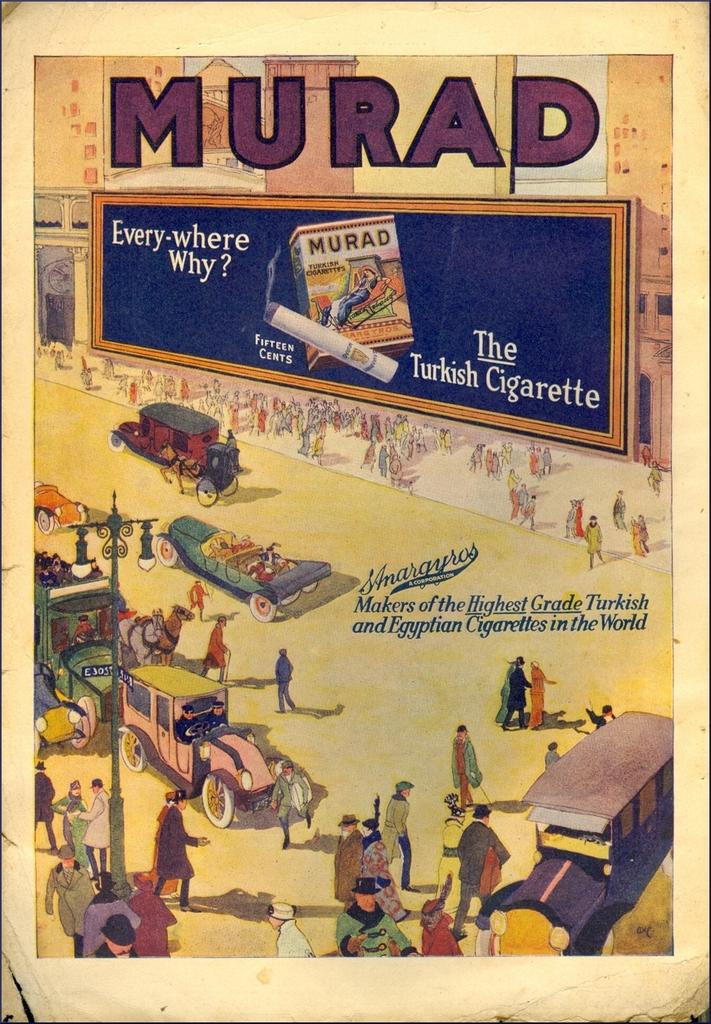What does it say at the top?
Make the answer very short. Murad. What product is the billboard advertising?
Your response must be concise. Murad. 